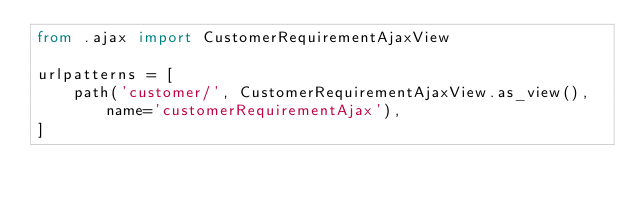Convert code to text. <code><loc_0><loc_0><loc_500><loc_500><_Python_>from .ajax import CustomerRequirementAjaxView

urlpatterns = [
    path('customer/', CustomerRequirementAjaxView.as_view(), name='customerRequirementAjax'),
]
</code> 